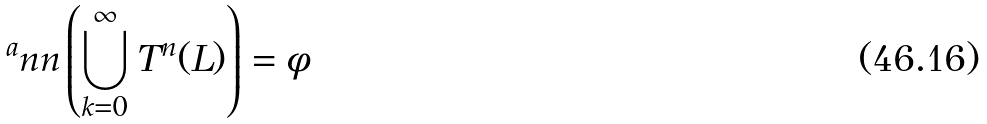Convert formula to latex. <formula><loc_0><loc_0><loc_500><loc_500>^ { a } n n \left ( \bigcup _ { k = 0 } ^ { \infty } T ^ { n } ( L ) \right ) = \phi</formula> 